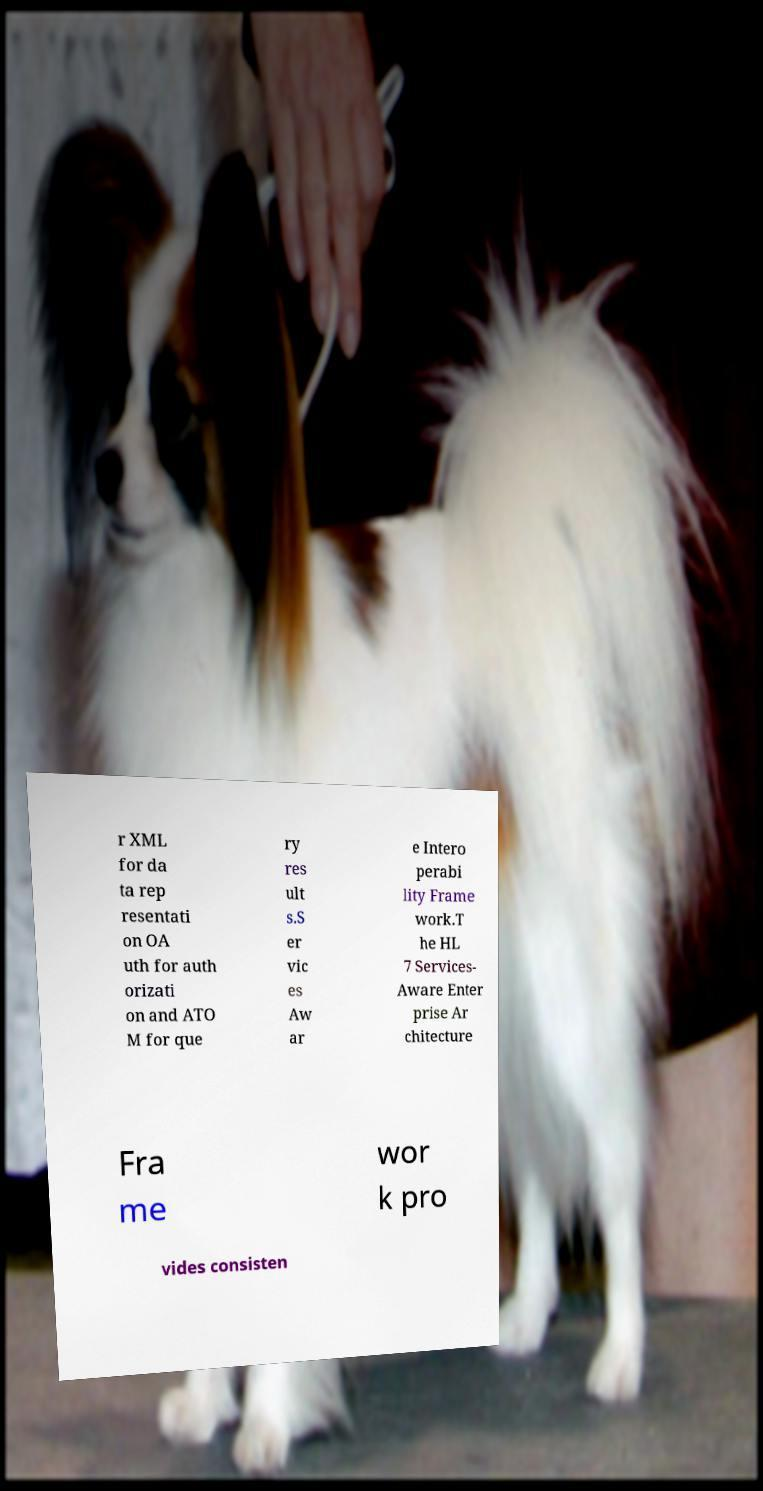Can you read and provide the text displayed in the image?This photo seems to have some interesting text. Can you extract and type it out for me? r XML for da ta rep resentati on OA uth for auth orizati on and ATO M for que ry res ult s.S er vic es Aw ar e Intero perabi lity Frame work.T he HL 7 Services- Aware Enter prise Ar chitecture Fra me wor k pro vides consisten 